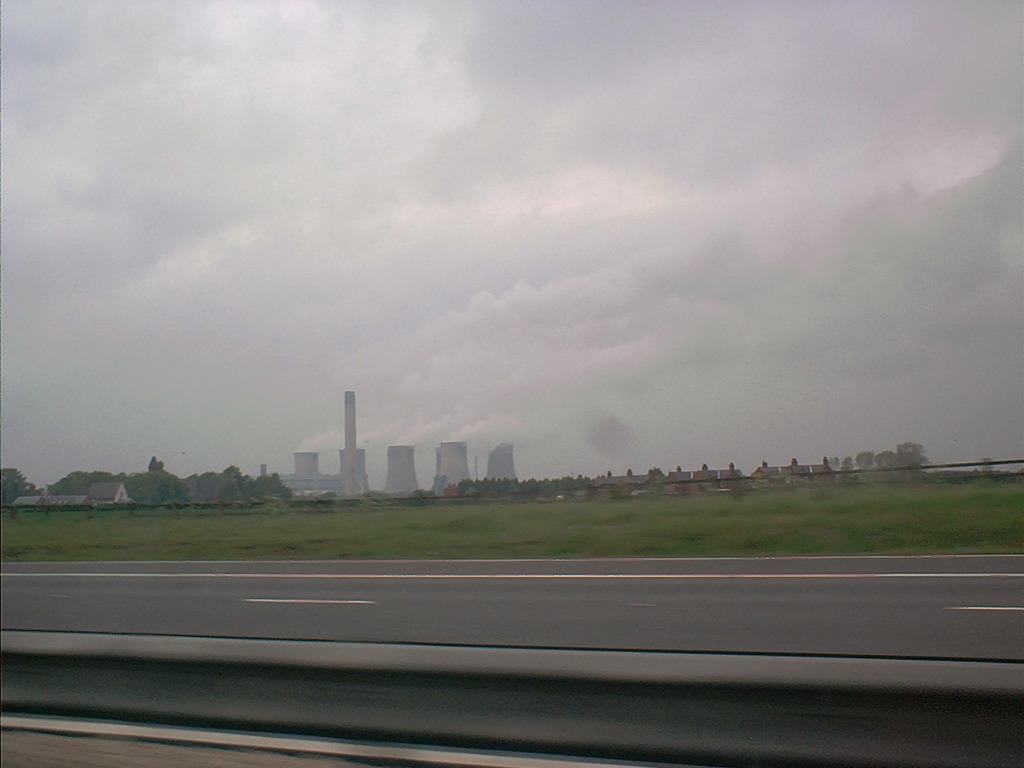What is the perspective of the image? The image is taken from a vehicle. What is at the bottom of the image? There is a road at the bottom of the image. What can be seen in the background of the image? There are buildings and green grass in the background of the image. What is visible in the sky at the top of the image? Clouds are visible in the sky at the top of the image. What type of head is visible in the image? There is no head visible in the image; it is taken from a vehicle and primarily shows a road, buildings, green grass, and clouds. 